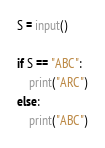Convert code to text. <code><loc_0><loc_0><loc_500><loc_500><_Python_>S = input()

if S == "ABC":
    print("ARC")
else:
    print("ABC")

</code> 